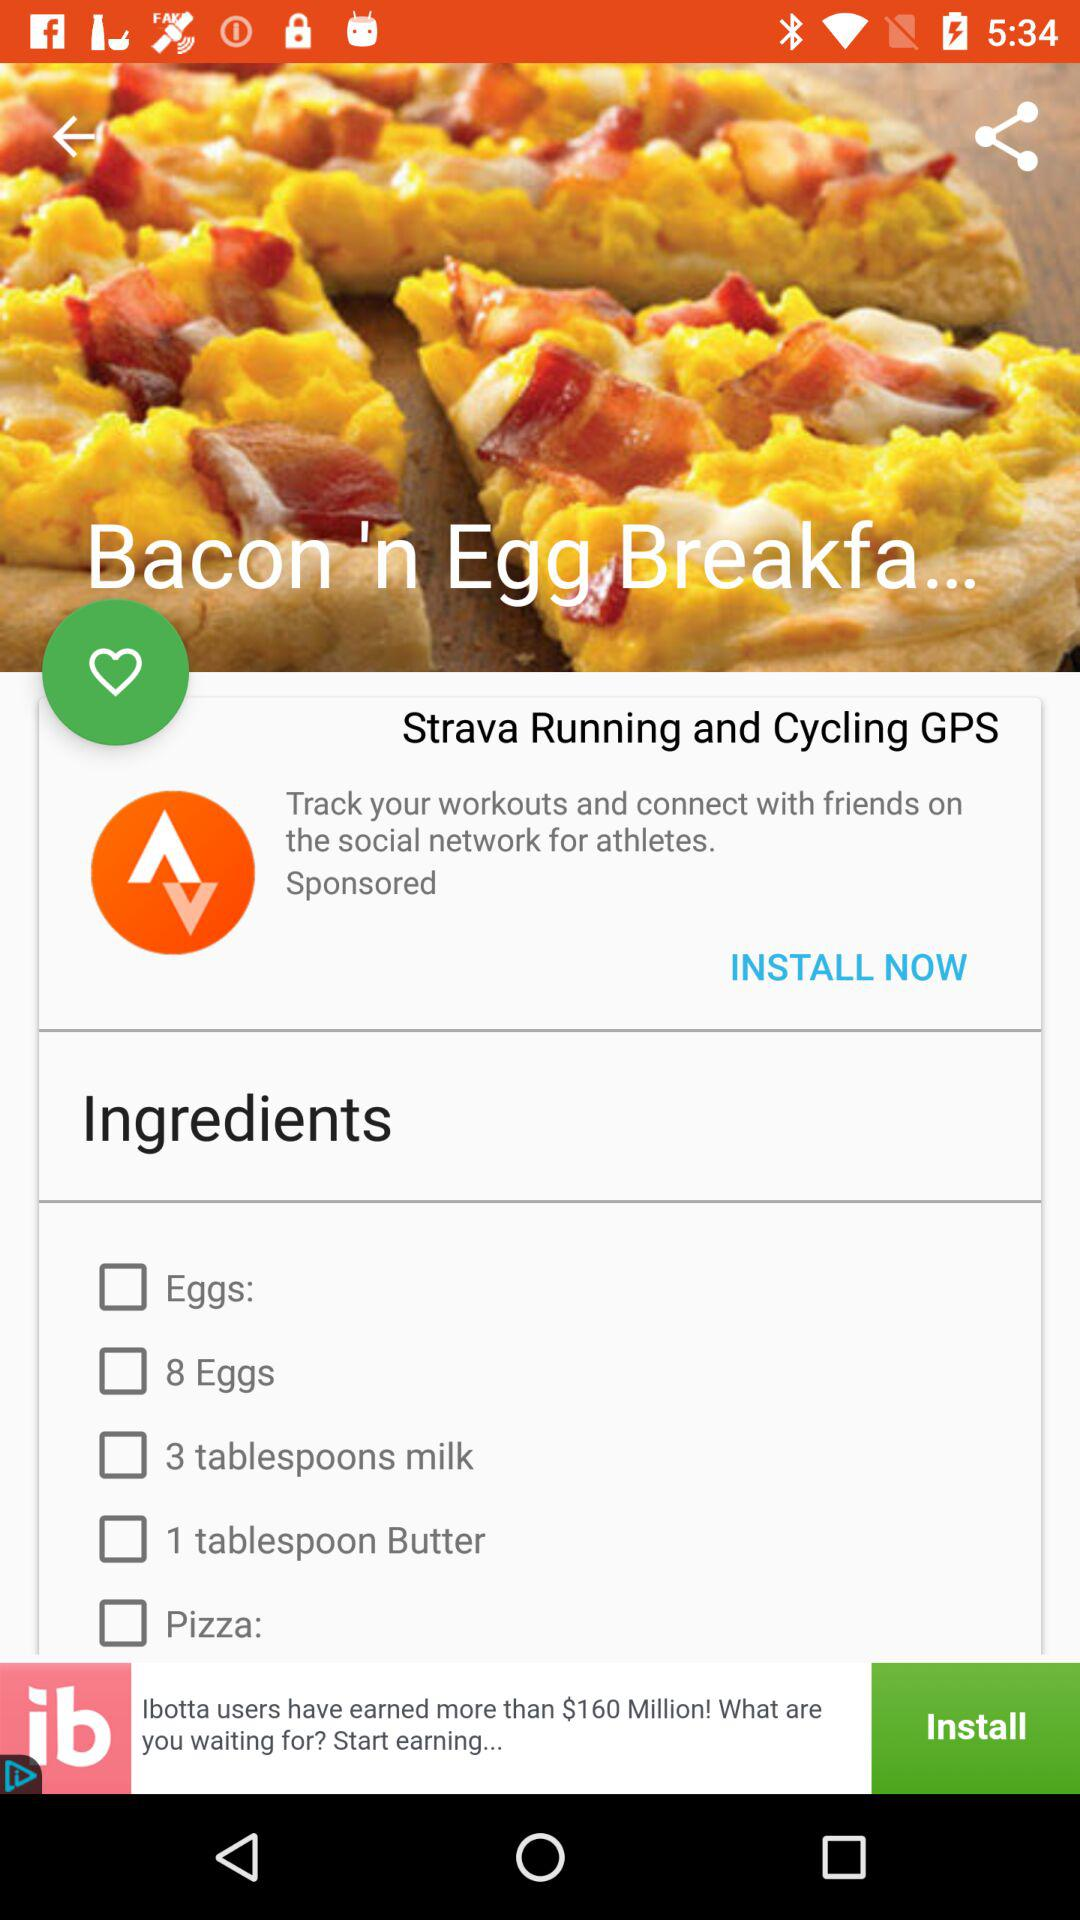What are the ingredients required for "Bacon 'n Egg"? The required ingredients are eggs, 8 eggs, 3 tablespoons milk, 1 tablespoon butter and pizza. 